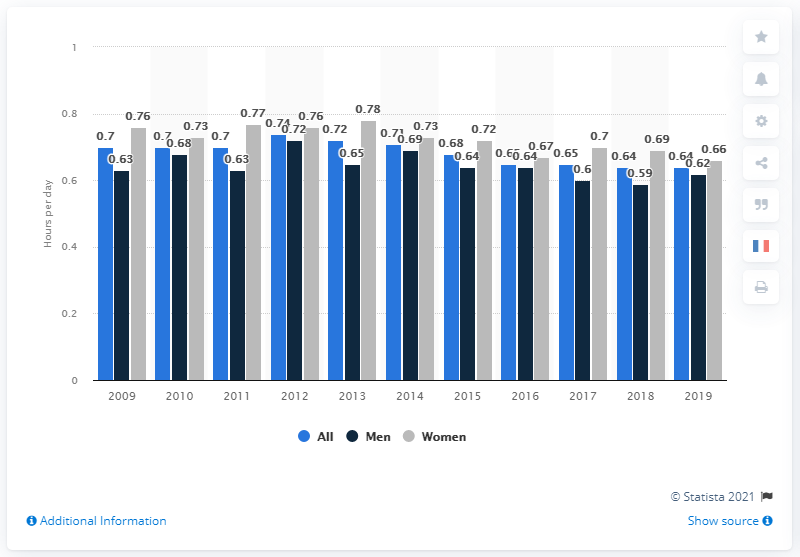Outline some significant characteristics in this image. In 2019, women spent an average of 0.66 hours per day communicating and socializing. This represents a significant amount of time spent on these activities and highlights the importance of communication and socialization in the lives of women. It is important to note that this data is an average and may vary depending on individual circumstances and factors such as age, occupation, and personal interests. 